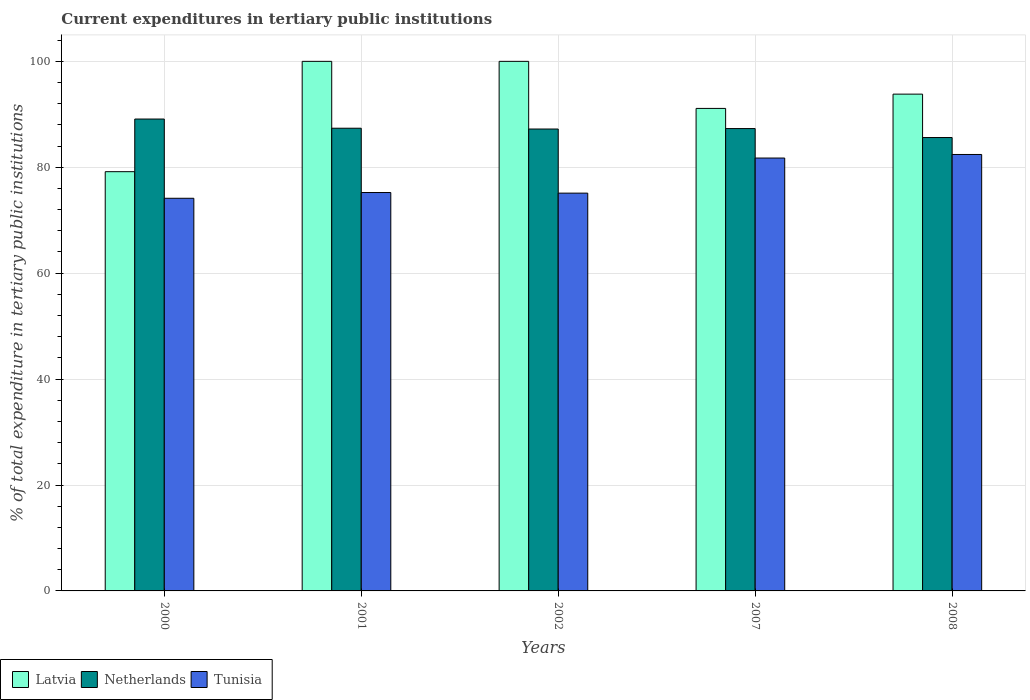Are the number of bars per tick equal to the number of legend labels?
Your response must be concise. Yes. How many bars are there on the 5th tick from the left?
Ensure brevity in your answer.  3. How many bars are there on the 3rd tick from the right?
Your answer should be very brief. 3. What is the label of the 2nd group of bars from the left?
Your response must be concise. 2001. In how many cases, is the number of bars for a given year not equal to the number of legend labels?
Offer a terse response. 0. What is the current expenditures in tertiary public institutions in Tunisia in 2001?
Provide a short and direct response. 75.23. Across all years, what is the maximum current expenditures in tertiary public institutions in Netherlands?
Provide a short and direct response. 89.11. Across all years, what is the minimum current expenditures in tertiary public institutions in Tunisia?
Ensure brevity in your answer.  74.15. In which year was the current expenditures in tertiary public institutions in Tunisia maximum?
Provide a succinct answer. 2008. In which year was the current expenditures in tertiary public institutions in Latvia minimum?
Provide a succinct answer. 2000. What is the total current expenditures in tertiary public institutions in Netherlands in the graph?
Offer a terse response. 436.62. What is the difference between the current expenditures in tertiary public institutions in Latvia in 2007 and that in 2008?
Offer a very short reply. -2.7. What is the difference between the current expenditures in tertiary public institutions in Netherlands in 2007 and the current expenditures in tertiary public institutions in Tunisia in 2008?
Your answer should be compact. 4.89. What is the average current expenditures in tertiary public institutions in Latvia per year?
Offer a terse response. 92.82. In the year 2002, what is the difference between the current expenditures in tertiary public institutions in Tunisia and current expenditures in tertiary public institutions in Latvia?
Provide a short and direct response. -24.88. What is the ratio of the current expenditures in tertiary public institutions in Tunisia in 2001 to that in 2008?
Provide a short and direct response. 0.91. What is the difference between the highest and the second highest current expenditures in tertiary public institutions in Tunisia?
Ensure brevity in your answer.  0.67. What is the difference between the highest and the lowest current expenditures in tertiary public institutions in Latvia?
Offer a terse response. 20.83. Is the sum of the current expenditures in tertiary public institutions in Latvia in 2000 and 2001 greater than the maximum current expenditures in tertiary public institutions in Netherlands across all years?
Your answer should be compact. Yes. What does the 1st bar from the left in 2001 represents?
Provide a succinct answer. Latvia. What does the 3rd bar from the right in 2007 represents?
Make the answer very short. Latvia. Is it the case that in every year, the sum of the current expenditures in tertiary public institutions in Latvia and current expenditures in tertiary public institutions in Netherlands is greater than the current expenditures in tertiary public institutions in Tunisia?
Keep it short and to the point. Yes. How many years are there in the graph?
Your answer should be very brief. 5. Does the graph contain any zero values?
Your response must be concise. No. Does the graph contain grids?
Make the answer very short. Yes. What is the title of the graph?
Your answer should be compact. Current expenditures in tertiary public institutions. What is the label or title of the X-axis?
Your answer should be very brief. Years. What is the label or title of the Y-axis?
Ensure brevity in your answer.  % of total expenditure in tertiary public institutions. What is the % of total expenditure in tertiary public institutions of Latvia in 2000?
Keep it short and to the point. 79.17. What is the % of total expenditure in tertiary public institutions in Netherlands in 2000?
Make the answer very short. 89.11. What is the % of total expenditure in tertiary public institutions in Tunisia in 2000?
Provide a succinct answer. 74.15. What is the % of total expenditure in tertiary public institutions in Netherlands in 2001?
Your answer should be very brief. 87.37. What is the % of total expenditure in tertiary public institutions of Tunisia in 2001?
Your response must be concise. 75.23. What is the % of total expenditure in tertiary public institutions in Netherlands in 2002?
Give a very brief answer. 87.22. What is the % of total expenditure in tertiary public institutions of Tunisia in 2002?
Your response must be concise. 75.12. What is the % of total expenditure in tertiary public institutions of Latvia in 2007?
Provide a succinct answer. 91.11. What is the % of total expenditure in tertiary public institutions in Netherlands in 2007?
Make the answer very short. 87.31. What is the % of total expenditure in tertiary public institutions of Tunisia in 2007?
Your answer should be compact. 81.74. What is the % of total expenditure in tertiary public institutions of Latvia in 2008?
Provide a short and direct response. 93.81. What is the % of total expenditure in tertiary public institutions in Netherlands in 2008?
Ensure brevity in your answer.  85.61. What is the % of total expenditure in tertiary public institutions of Tunisia in 2008?
Offer a very short reply. 82.41. Across all years, what is the maximum % of total expenditure in tertiary public institutions in Netherlands?
Keep it short and to the point. 89.11. Across all years, what is the maximum % of total expenditure in tertiary public institutions in Tunisia?
Give a very brief answer. 82.41. Across all years, what is the minimum % of total expenditure in tertiary public institutions of Latvia?
Your response must be concise. 79.17. Across all years, what is the minimum % of total expenditure in tertiary public institutions of Netherlands?
Ensure brevity in your answer.  85.61. Across all years, what is the minimum % of total expenditure in tertiary public institutions of Tunisia?
Offer a very short reply. 74.15. What is the total % of total expenditure in tertiary public institutions of Latvia in the graph?
Provide a short and direct response. 464.09. What is the total % of total expenditure in tertiary public institutions of Netherlands in the graph?
Your answer should be compact. 436.62. What is the total % of total expenditure in tertiary public institutions of Tunisia in the graph?
Provide a short and direct response. 388.65. What is the difference between the % of total expenditure in tertiary public institutions of Latvia in 2000 and that in 2001?
Offer a very short reply. -20.83. What is the difference between the % of total expenditure in tertiary public institutions of Netherlands in 2000 and that in 2001?
Provide a succinct answer. 1.74. What is the difference between the % of total expenditure in tertiary public institutions of Tunisia in 2000 and that in 2001?
Provide a succinct answer. -1.08. What is the difference between the % of total expenditure in tertiary public institutions of Latvia in 2000 and that in 2002?
Offer a very short reply. -20.83. What is the difference between the % of total expenditure in tertiary public institutions of Netherlands in 2000 and that in 2002?
Your response must be concise. 1.89. What is the difference between the % of total expenditure in tertiary public institutions in Tunisia in 2000 and that in 2002?
Ensure brevity in your answer.  -0.97. What is the difference between the % of total expenditure in tertiary public institutions in Latvia in 2000 and that in 2007?
Make the answer very short. -11.95. What is the difference between the % of total expenditure in tertiary public institutions in Netherlands in 2000 and that in 2007?
Ensure brevity in your answer.  1.8. What is the difference between the % of total expenditure in tertiary public institutions of Tunisia in 2000 and that in 2007?
Your answer should be very brief. -7.6. What is the difference between the % of total expenditure in tertiary public institutions in Latvia in 2000 and that in 2008?
Offer a terse response. -14.64. What is the difference between the % of total expenditure in tertiary public institutions in Netherlands in 2000 and that in 2008?
Offer a terse response. 3.5. What is the difference between the % of total expenditure in tertiary public institutions of Tunisia in 2000 and that in 2008?
Make the answer very short. -8.27. What is the difference between the % of total expenditure in tertiary public institutions in Latvia in 2001 and that in 2002?
Offer a terse response. 0. What is the difference between the % of total expenditure in tertiary public institutions of Netherlands in 2001 and that in 2002?
Offer a very short reply. 0.15. What is the difference between the % of total expenditure in tertiary public institutions of Tunisia in 2001 and that in 2002?
Keep it short and to the point. 0.12. What is the difference between the % of total expenditure in tertiary public institutions of Latvia in 2001 and that in 2007?
Make the answer very short. 8.89. What is the difference between the % of total expenditure in tertiary public institutions of Netherlands in 2001 and that in 2007?
Make the answer very short. 0.06. What is the difference between the % of total expenditure in tertiary public institutions of Tunisia in 2001 and that in 2007?
Give a very brief answer. -6.51. What is the difference between the % of total expenditure in tertiary public institutions of Latvia in 2001 and that in 2008?
Your answer should be very brief. 6.19. What is the difference between the % of total expenditure in tertiary public institutions of Netherlands in 2001 and that in 2008?
Offer a very short reply. 1.76. What is the difference between the % of total expenditure in tertiary public institutions in Tunisia in 2001 and that in 2008?
Give a very brief answer. -7.18. What is the difference between the % of total expenditure in tertiary public institutions in Latvia in 2002 and that in 2007?
Give a very brief answer. 8.89. What is the difference between the % of total expenditure in tertiary public institutions of Netherlands in 2002 and that in 2007?
Give a very brief answer. -0.09. What is the difference between the % of total expenditure in tertiary public institutions in Tunisia in 2002 and that in 2007?
Offer a terse response. -6.63. What is the difference between the % of total expenditure in tertiary public institutions in Latvia in 2002 and that in 2008?
Your answer should be very brief. 6.19. What is the difference between the % of total expenditure in tertiary public institutions in Netherlands in 2002 and that in 2008?
Offer a very short reply. 1.61. What is the difference between the % of total expenditure in tertiary public institutions in Tunisia in 2002 and that in 2008?
Provide a succinct answer. -7.3. What is the difference between the % of total expenditure in tertiary public institutions in Latvia in 2007 and that in 2008?
Your response must be concise. -2.7. What is the difference between the % of total expenditure in tertiary public institutions of Netherlands in 2007 and that in 2008?
Your response must be concise. 1.69. What is the difference between the % of total expenditure in tertiary public institutions of Tunisia in 2007 and that in 2008?
Your response must be concise. -0.67. What is the difference between the % of total expenditure in tertiary public institutions in Latvia in 2000 and the % of total expenditure in tertiary public institutions in Netherlands in 2001?
Offer a very short reply. -8.2. What is the difference between the % of total expenditure in tertiary public institutions in Latvia in 2000 and the % of total expenditure in tertiary public institutions in Tunisia in 2001?
Offer a terse response. 3.94. What is the difference between the % of total expenditure in tertiary public institutions in Netherlands in 2000 and the % of total expenditure in tertiary public institutions in Tunisia in 2001?
Offer a very short reply. 13.88. What is the difference between the % of total expenditure in tertiary public institutions of Latvia in 2000 and the % of total expenditure in tertiary public institutions of Netherlands in 2002?
Provide a short and direct response. -8.05. What is the difference between the % of total expenditure in tertiary public institutions in Latvia in 2000 and the % of total expenditure in tertiary public institutions in Tunisia in 2002?
Give a very brief answer. 4.05. What is the difference between the % of total expenditure in tertiary public institutions in Netherlands in 2000 and the % of total expenditure in tertiary public institutions in Tunisia in 2002?
Offer a very short reply. 13.99. What is the difference between the % of total expenditure in tertiary public institutions of Latvia in 2000 and the % of total expenditure in tertiary public institutions of Netherlands in 2007?
Your response must be concise. -8.14. What is the difference between the % of total expenditure in tertiary public institutions of Latvia in 2000 and the % of total expenditure in tertiary public institutions of Tunisia in 2007?
Give a very brief answer. -2.58. What is the difference between the % of total expenditure in tertiary public institutions of Netherlands in 2000 and the % of total expenditure in tertiary public institutions of Tunisia in 2007?
Provide a short and direct response. 7.36. What is the difference between the % of total expenditure in tertiary public institutions in Latvia in 2000 and the % of total expenditure in tertiary public institutions in Netherlands in 2008?
Keep it short and to the point. -6.45. What is the difference between the % of total expenditure in tertiary public institutions in Latvia in 2000 and the % of total expenditure in tertiary public institutions in Tunisia in 2008?
Keep it short and to the point. -3.25. What is the difference between the % of total expenditure in tertiary public institutions in Netherlands in 2000 and the % of total expenditure in tertiary public institutions in Tunisia in 2008?
Provide a short and direct response. 6.69. What is the difference between the % of total expenditure in tertiary public institutions in Latvia in 2001 and the % of total expenditure in tertiary public institutions in Netherlands in 2002?
Offer a terse response. 12.78. What is the difference between the % of total expenditure in tertiary public institutions in Latvia in 2001 and the % of total expenditure in tertiary public institutions in Tunisia in 2002?
Your answer should be compact. 24.88. What is the difference between the % of total expenditure in tertiary public institutions of Netherlands in 2001 and the % of total expenditure in tertiary public institutions of Tunisia in 2002?
Give a very brief answer. 12.26. What is the difference between the % of total expenditure in tertiary public institutions in Latvia in 2001 and the % of total expenditure in tertiary public institutions in Netherlands in 2007?
Give a very brief answer. 12.69. What is the difference between the % of total expenditure in tertiary public institutions of Latvia in 2001 and the % of total expenditure in tertiary public institutions of Tunisia in 2007?
Keep it short and to the point. 18.26. What is the difference between the % of total expenditure in tertiary public institutions in Netherlands in 2001 and the % of total expenditure in tertiary public institutions in Tunisia in 2007?
Your response must be concise. 5.63. What is the difference between the % of total expenditure in tertiary public institutions of Latvia in 2001 and the % of total expenditure in tertiary public institutions of Netherlands in 2008?
Offer a very short reply. 14.39. What is the difference between the % of total expenditure in tertiary public institutions in Latvia in 2001 and the % of total expenditure in tertiary public institutions in Tunisia in 2008?
Keep it short and to the point. 17.59. What is the difference between the % of total expenditure in tertiary public institutions in Netherlands in 2001 and the % of total expenditure in tertiary public institutions in Tunisia in 2008?
Provide a succinct answer. 4.96. What is the difference between the % of total expenditure in tertiary public institutions of Latvia in 2002 and the % of total expenditure in tertiary public institutions of Netherlands in 2007?
Your answer should be very brief. 12.69. What is the difference between the % of total expenditure in tertiary public institutions in Latvia in 2002 and the % of total expenditure in tertiary public institutions in Tunisia in 2007?
Offer a very short reply. 18.26. What is the difference between the % of total expenditure in tertiary public institutions in Netherlands in 2002 and the % of total expenditure in tertiary public institutions in Tunisia in 2007?
Keep it short and to the point. 5.48. What is the difference between the % of total expenditure in tertiary public institutions in Latvia in 2002 and the % of total expenditure in tertiary public institutions in Netherlands in 2008?
Your answer should be very brief. 14.39. What is the difference between the % of total expenditure in tertiary public institutions in Latvia in 2002 and the % of total expenditure in tertiary public institutions in Tunisia in 2008?
Your answer should be very brief. 17.59. What is the difference between the % of total expenditure in tertiary public institutions of Netherlands in 2002 and the % of total expenditure in tertiary public institutions of Tunisia in 2008?
Your response must be concise. 4.81. What is the difference between the % of total expenditure in tertiary public institutions of Latvia in 2007 and the % of total expenditure in tertiary public institutions of Netherlands in 2008?
Your answer should be very brief. 5.5. What is the difference between the % of total expenditure in tertiary public institutions in Latvia in 2007 and the % of total expenditure in tertiary public institutions in Tunisia in 2008?
Ensure brevity in your answer.  8.7. What is the difference between the % of total expenditure in tertiary public institutions of Netherlands in 2007 and the % of total expenditure in tertiary public institutions of Tunisia in 2008?
Your answer should be very brief. 4.89. What is the average % of total expenditure in tertiary public institutions in Latvia per year?
Give a very brief answer. 92.82. What is the average % of total expenditure in tertiary public institutions in Netherlands per year?
Provide a short and direct response. 87.32. What is the average % of total expenditure in tertiary public institutions in Tunisia per year?
Ensure brevity in your answer.  77.73. In the year 2000, what is the difference between the % of total expenditure in tertiary public institutions in Latvia and % of total expenditure in tertiary public institutions in Netherlands?
Keep it short and to the point. -9.94. In the year 2000, what is the difference between the % of total expenditure in tertiary public institutions in Latvia and % of total expenditure in tertiary public institutions in Tunisia?
Your answer should be compact. 5.02. In the year 2000, what is the difference between the % of total expenditure in tertiary public institutions in Netherlands and % of total expenditure in tertiary public institutions in Tunisia?
Ensure brevity in your answer.  14.96. In the year 2001, what is the difference between the % of total expenditure in tertiary public institutions in Latvia and % of total expenditure in tertiary public institutions in Netherlands?
Provide a succinct answer. 12.63. In the year 2001, what is the difference between the % of total expenditure in tertiary public institutions in Latvia and % of total expenditure in tertiary public institutions in Tunisia?
Give a very brief answer. 24.77. In the year 2001, what is the difference between the % of total expenditure in tertiary public institutions in Netherlands and % of total expenditure in tertiary public institutions in Tunisia?
Keep it short and to the point. 12.14. In the year 2002, what is the difference between the % of total expenditure in tertiary public institutions in Latvia and % of total expenditure in tertiary public institutions in Netherlands?
Keep it short and to the point. 12.78. In the year 2002, what is the difference between the % of total expenditure in tertiary public institutions of Latvia and % of total expenditure in tertiary public institutions of Tunisia?
Your answer should be very brief. 24.88. In the year 2002, what is the difference between the % of total expenditure in tertiary public institutions of Netherlands and % of total expenditure in tertiary public institutions of Tunisia?
Make the answer very short. 12.11. In the year 2007, what is the difference between the % of total expenditure in tertiary public institutions of Latvia and % of total expenditure in tertiary public institutions of Netherlands?
Provide a succinct answer. 3.81. In the year 2007, what is the difference between the % of total expenditure in tertiary public institutions of Latvia and % of total expenditure in tertiary public institutions of Tunisia?
Your answer should be very brief. 9.37. In the year 2007, what is the difference between the % of total expenditure in tertiary public institutions in Netherlands and % of total expenditure in tertiary public institutions in Tunisia?
Offer a terse response. 5.56. In the year 2008, what is the difference between the % of total expenditure in tertiary public institutions in Latvia and % of total expenditure in tertiary public institutions in Netherlands?
Provide a succinct answer. 8.2. In the year 2008, what is the difference between the % of total expenditure in tertiary public institutions of Latvia and % of total expenditure in tertiary public institutions of Tunisia?
Your answer should be compact. 11.4. In the year 2008, what is the difference between the % of total expenditure in tertiary public institutions in Netherlands and % of total expenditure in tertiary public institutions in Tunisia?
Your answer should be very brief. 3.2. What is the ratio of the % of total expenditure in tertiary public institutions in Latvia in 2000 to that in 2001?
Offer a very short reply. 0.79. What is the ratio of the % of total expenditure in tertiary public institutions in Netherlands in 2000 to that in 2001?
Offer a terse response. 1.02. What is the ratio of the % of total expenditure in tertiary public institutions in Tunisia in 2000 to that in 2001?
Make the answer very short. 0.99. What is the ratio of the % of total expenditure in tertiary public institutions in Latvia in 2000 to that in 2002?
Make the answer very short. 0.79. What is the ratio of the % of total expenditure in tertiary public institutions of Netherlands in 2000 to that in 2002?
Provide a succinct answer. 1.02. What is the ratio of the % of total expenditure in tertiary public institutions in Tunisia in 2000 to that in 2002?
Provide a succinct answer. 0.99. What is the ratio of the % of total expenditure in tertiary public institutions of Latvia in 2000 to that in 2007?
Your answer should be very brief. 0.87. What is the ratio of the % of total expenditure in tertiary public institutions in Netherlands in 2000 to that in 2007?
Give a very brief answer. 1.02. What is the ratio of the % of total expenditure in tertiary public institutions of Tunisia in 2000 to that in 2007?
Offer a terse response. 0.91. What is the ratio of the % of total expenditure in tertiary public institutions in Latvia in 2000 to that in 2008?
Offer a very short reply. 0.84. What is the ratio of the % of total expenditure in tertiary public institutions in Netherlands in 2000 to that in 2008?
Make the answer very short. 1.04. What is the ratio of the % of total expenditure in tertiary public institutions in Tunisia in 2000 to that in 2008?
Your response must be concise. 0.9. What is the ratio of the % of total expenditure in tertiary public institutions of Latvia in 2001 to that in 2002?
Give a very brief answer. 1. What is the ratio of the % of total expenditure in tertiary public institutions of Latvia in 2001 to that in 2007?
Keep it short and to the point. 1.1. What is the ratio of the % of total expenditure in tertiary public institutions in Netherlands in 2001 to that in 2007?
Make the answer very short. 1. What is the ratio of the % of total expenditure in tertiary public institutions of Tunisia in 2001 to that in 2007?
Keep it short and to the point. 0.92. What is the ratio of the % of total expenditure in tertiary public institutions of Latvia in 2001 to that in 2008?
Offer a terse response. 1.07. What is the ratio of the % of total expenditure in tertiary public institutions of Netherlands in 2001 to that in 2008?
Offer a very short reply. 1.02. What is the ratio of the % of total expenditure in tertiary public institutions of Tunisia in 2001 to that in 2008?
Your response must be concise. 0.91. What is the ratio of the % of total expenditure in tertiary public institutions of Latvia in 2002 to that in 2007?
Provide a short and direct response. 1.1. What is the ratio of the % of total expenditure in tertiary public institutions in Netherlands in 2002 to that in 2007?
Offer a very short reply. 1. What is the ratio of the % of total expenditure in tertiary public institutions of Tunisia in 2002 to that in 2007?
Keep it short and to the point. 0.92. What is the ratio of the % of total expenditure in tertiary public institutions in Latvia in 2002 to that in 2008?
Your response must be concise. 1.07. What is the ratio of the % of total expenditure in tertiary public institutions of Netherlands in 2002 to that in 2008?
Ensure brevity in your answer.  1.02. What is the ratio of the % of total expenditure in tertiary public institutions of Tunisia in 2002 to that in 2008?
Make the answer very short. 0.91. What is the ratio of the % of total expenditure in tertiary public institutions in Latvia in 2007 to that in 2008?
Ensure brevity in your answer.  0.97. What is the ratio of the % of total expenditure in tertiary public institutions in Netherlands in 2007 to that in 2008?
Your answer should be very brief. 1.02. What is the difference between the highest and the second highest % of total expenditure in tertiary public institutions of Netherlands?
Offer a very short reply. 1.74. What is the difference between the highest and the second highest % of total expenditure in tertiary public institutions in Tunisia?
Your response must be concise. 0.67. What is the difference between the highest and the lowest % of total expenditure in tertiary public institutions of Latvia?
Keep it short and to the point. 20.83. What is the difference between the highest and the lowest % of total expenditure in tertiary public institutions of Netherlands?
Give a very brief answer. 3.5. What is the difference between the highest and the lowest % of total expenditure in tertiary public institutions in Tunisia?
Provide a succinct answer. 8.27. 